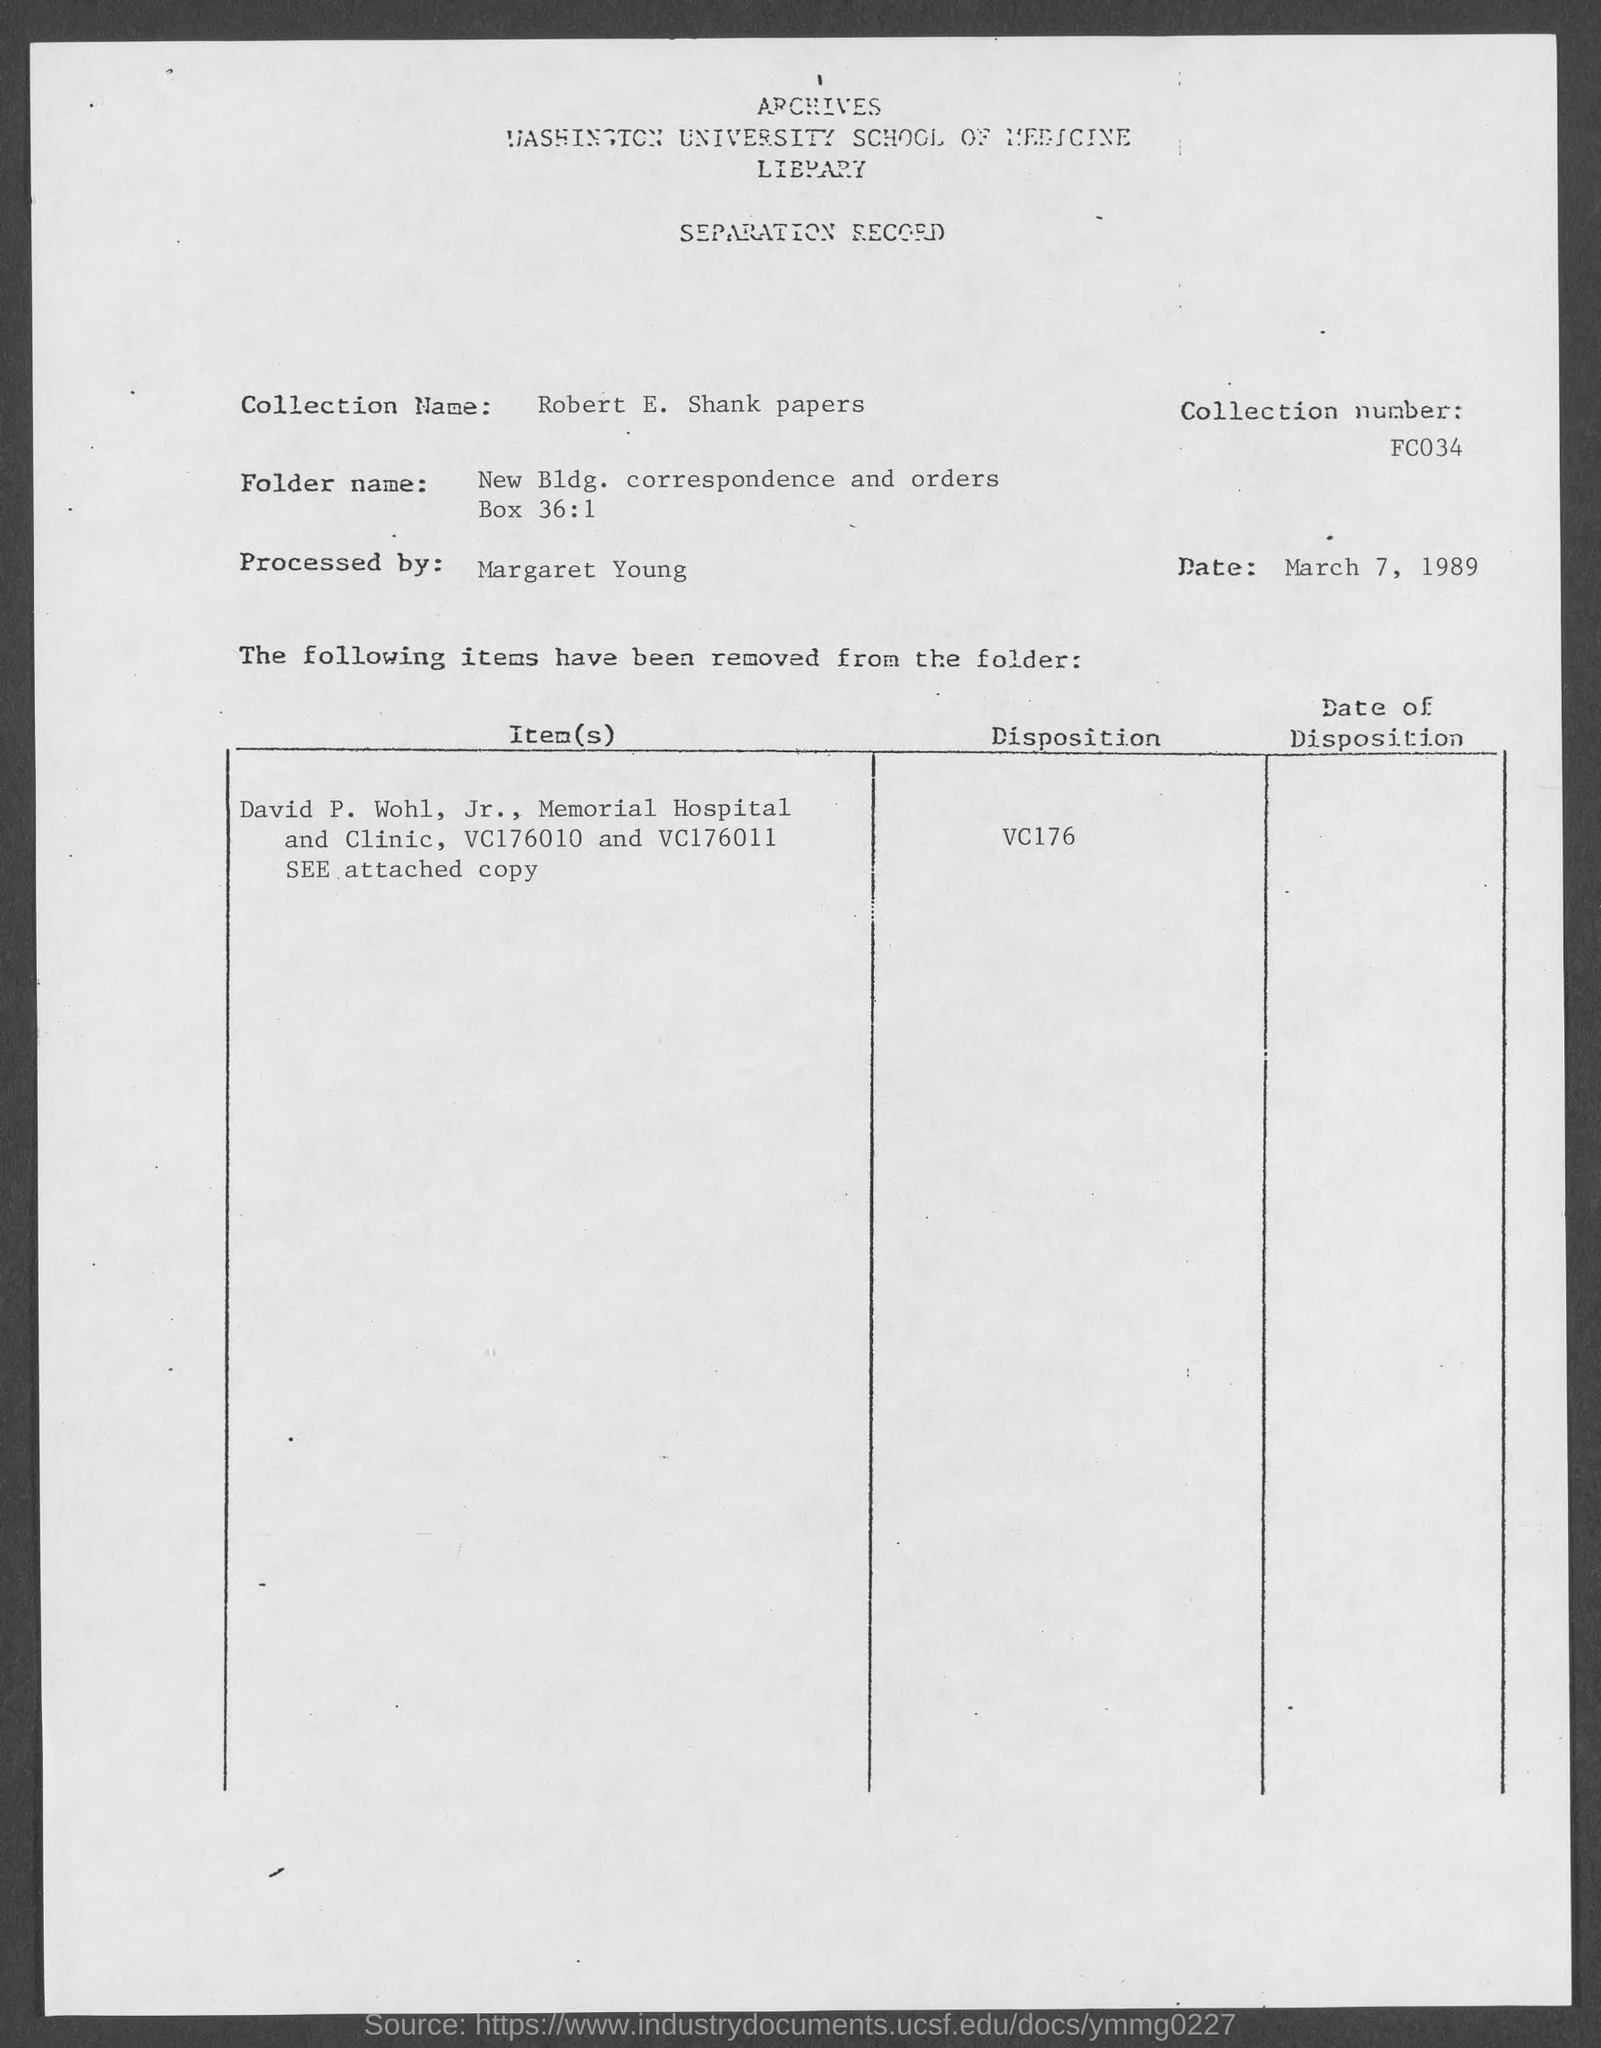Draw attention to some important aspects in this diagram. The date mentioned in the separation record is March 7, 1989. The collection name mentioned in the separation record is "Robert E. Shank Papers. The collection number mentioned in the record is FC034. 